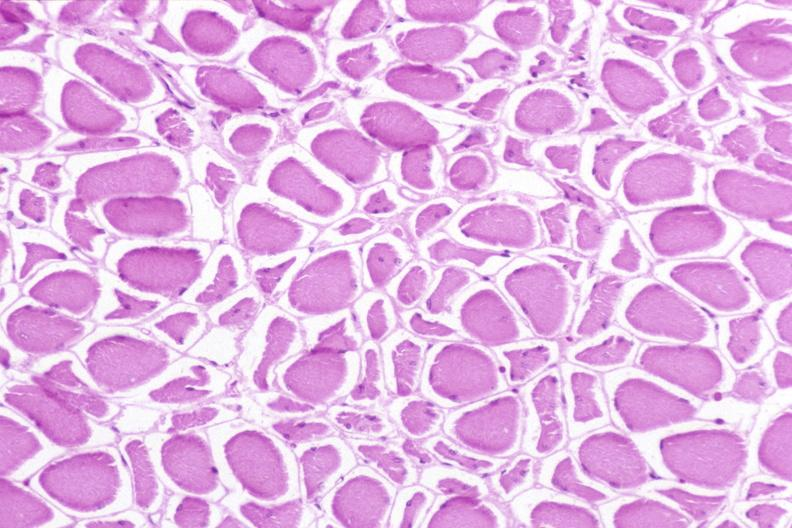what is present?
Answer the question using a single word or phrase. Musculoskeletal 